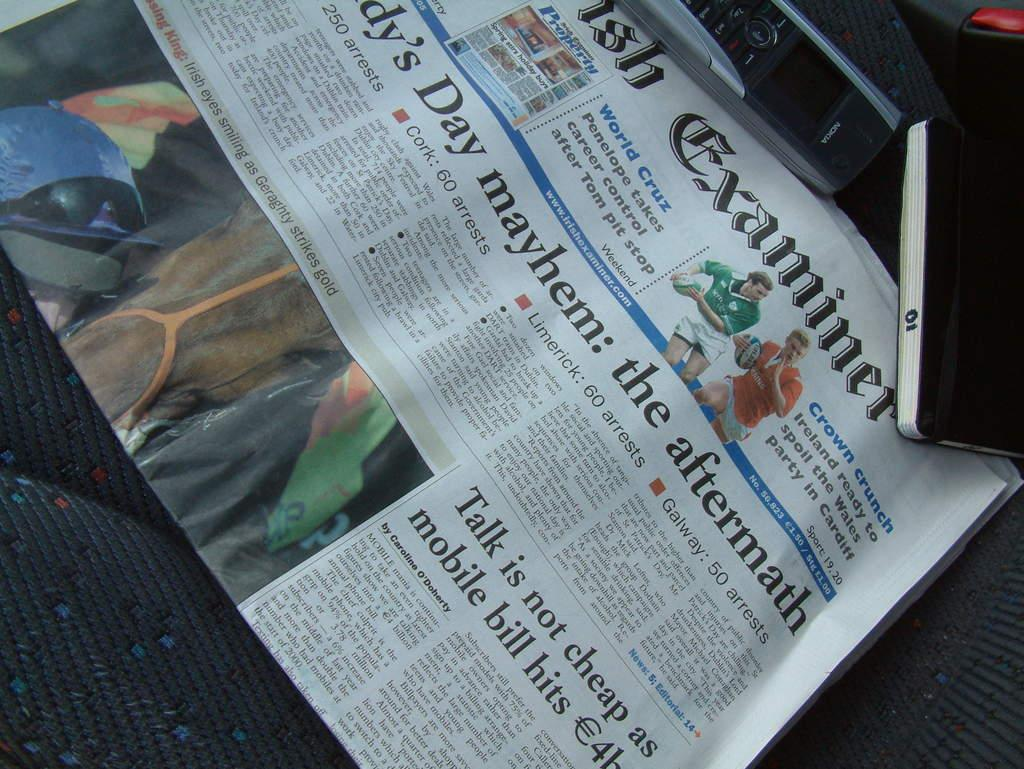<image>
Summarize the visual content of the image. A newspaper headline reports 250 arrests on the front page. 